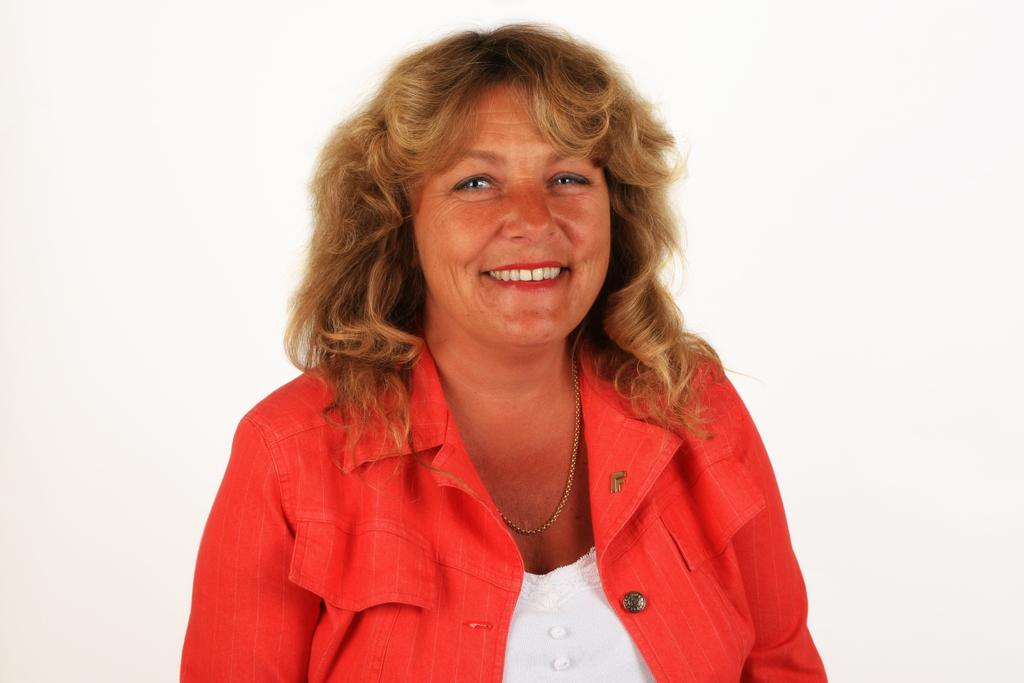Who is present in the image? There is a woman in the image. What is the woman doing in the image? The woman is smiling in the image. What is the woman wearing in the image? The woman is wearing a red jacket in the image. What is the color of the background in the image? The background of the image is white in color. How many giants can be seen in the image? There are no giants present in the image. What type of plastic material is visible in the image? There is no plastic material visible in the image. 